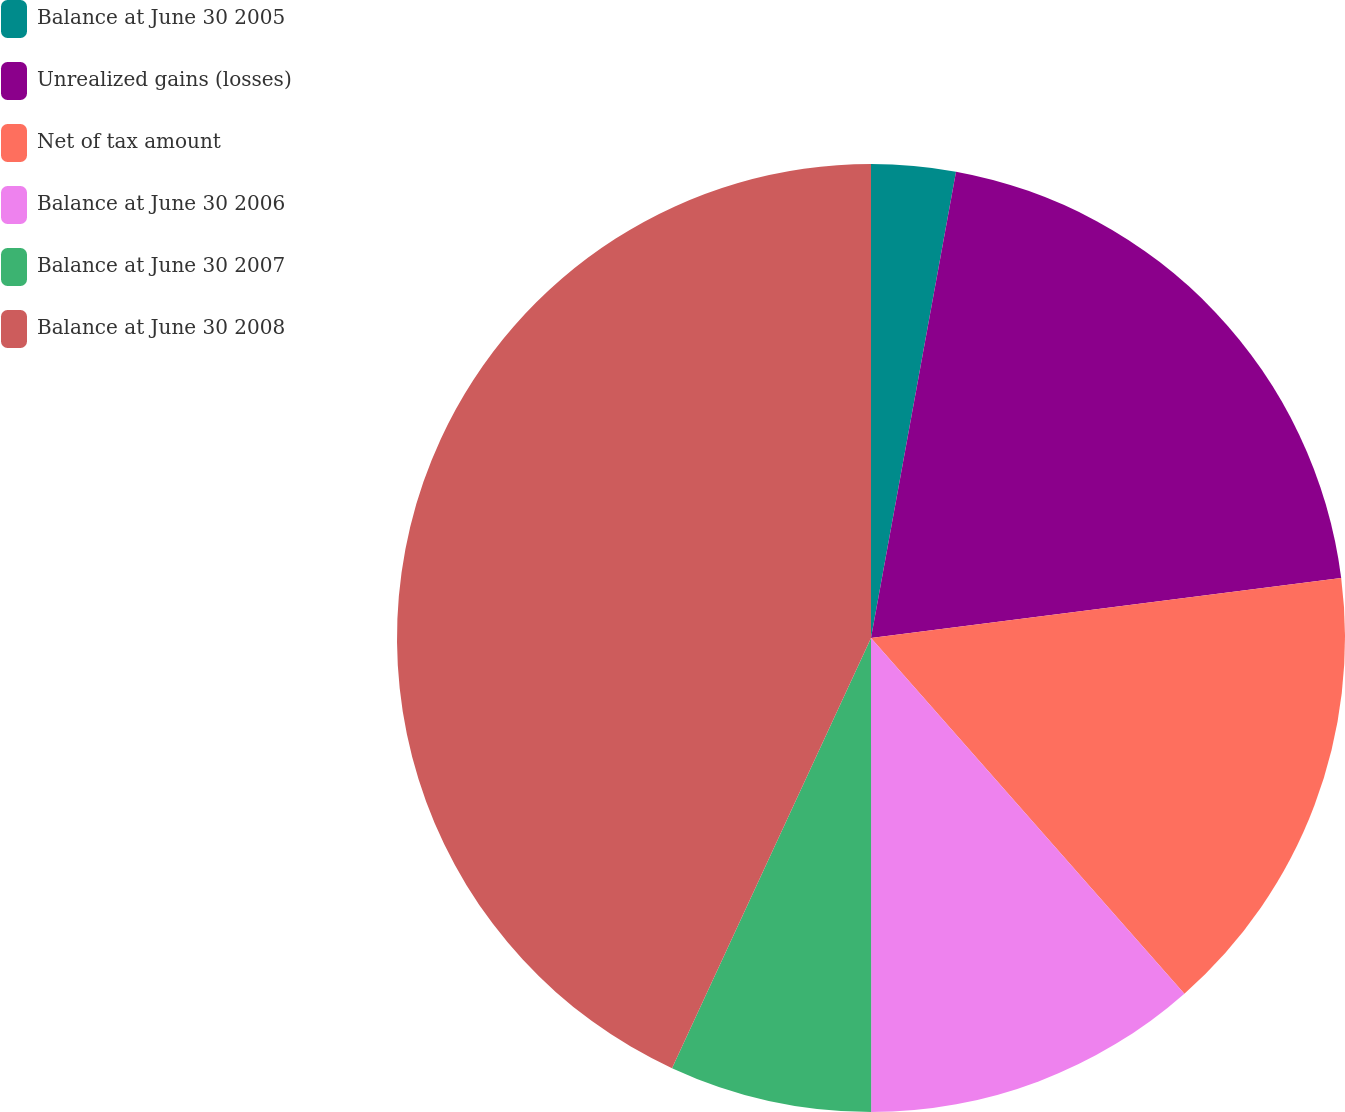Convert chart. <chart><loc_0><loc_0><loc_500><loc_500><pie_chart><fcel>Balance at June 30 2005<fcel>Unrealized gains (losses)<fcel>Net of tax amount<fcel>Balance at June 30 2006<fcel>Balance at June 30 2007<fcel>Balance at June 30 2008<nl><fcel>2.87%<fcel>20.11%<fcel>15.52%<fcel>11.49%<fcel>6.9%<fcel>43.1%<nl></chart> 